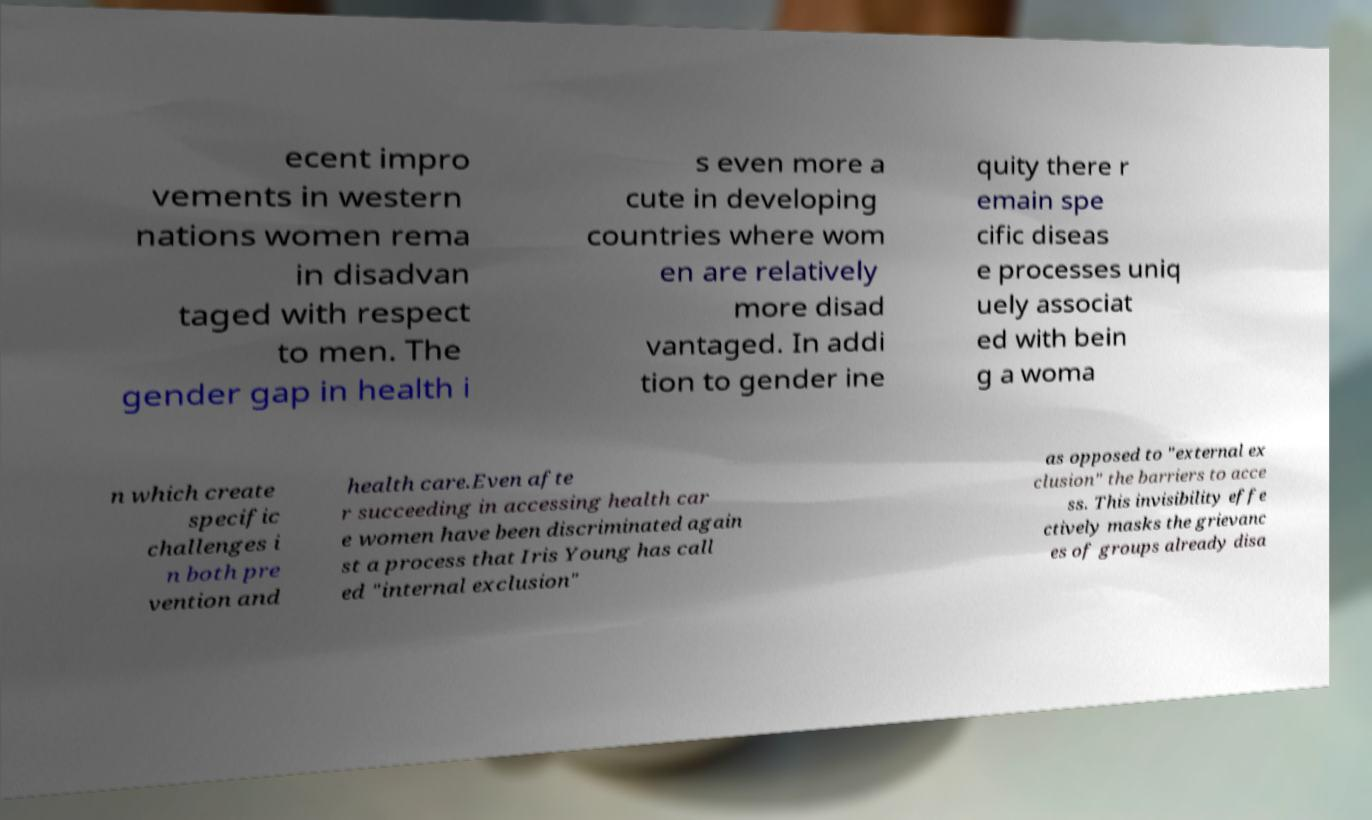I need the written content from this picture converted into text. Can you do that? ecent impro vements in western nations women rema in disadvan taged with respect to men. The gender gap in health i s even more a cute in developing countries where wom en are relatively more disad vantaged. In addi tion to gender ine quity there r emain spe cific diseas e processes uniq uely associat ed with bein g a woma n which create specific challenges i n both pre vention and health care.Even afte r succeeding in accessing health car e women have been discriminated again st a process that Iris Young has call ed "internal exclusion" as opposed to "external ex clusion" the barriers to acce ss. This invisibility effe ctively masks the grievanc es of groups already disa 